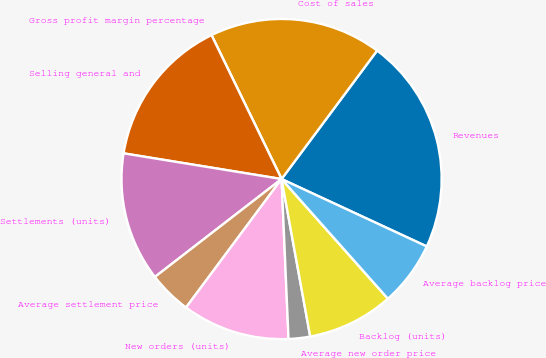Convert chart. <chart><loc_0><loc_0><loc_500><loc_500><pie_chart><fcel>Revenues<fcel>Cost of sales<fcel>Gross profit margin percentage<fcel>Selling general and<fcel>Settlements (units)<fcel>Average settlement price<fcel>New orders (units)<fcel>Average new order price<fcel>Backlog (units)<fcel>Average backlog price<nl><fcel>21.74%<fcel>17.39%<fcel>0.0%<fcel>15.22%<fcel>13.04%<fcel>4.35%<fcel>10.87%<fcel>2.17%<fcel>8.7%<fcel>6.52%<nl></chart> 